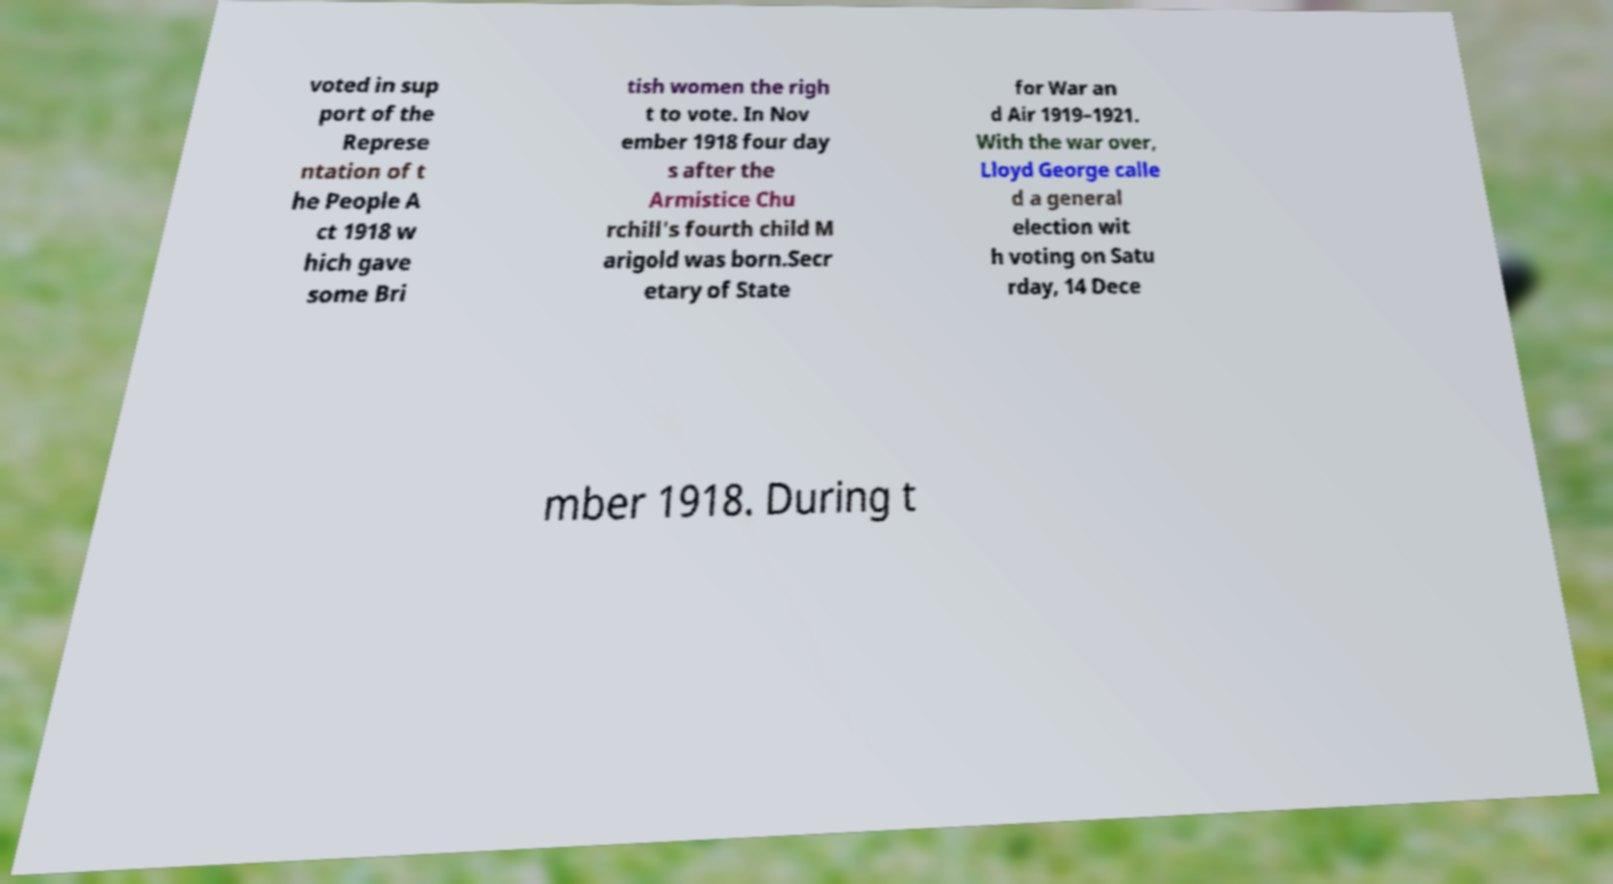Can you read and provide the text displayed in the image?This photo seems to have some interesting text. Can you extract and type it out for me? voted in sup port of the Represe ntation of t he People A ct 1918 w hich gave some Bri tish women the righ t to vote. In Nov ember 1918 four day s after the Armistice Chu rchill's fourth child M arigold was born.Secr etary of State for War an d Air 1919–1921. With the war over, Lloyd George calle d a general election wit h voting on Satu rday, 14 Dece mber 1918. During t 